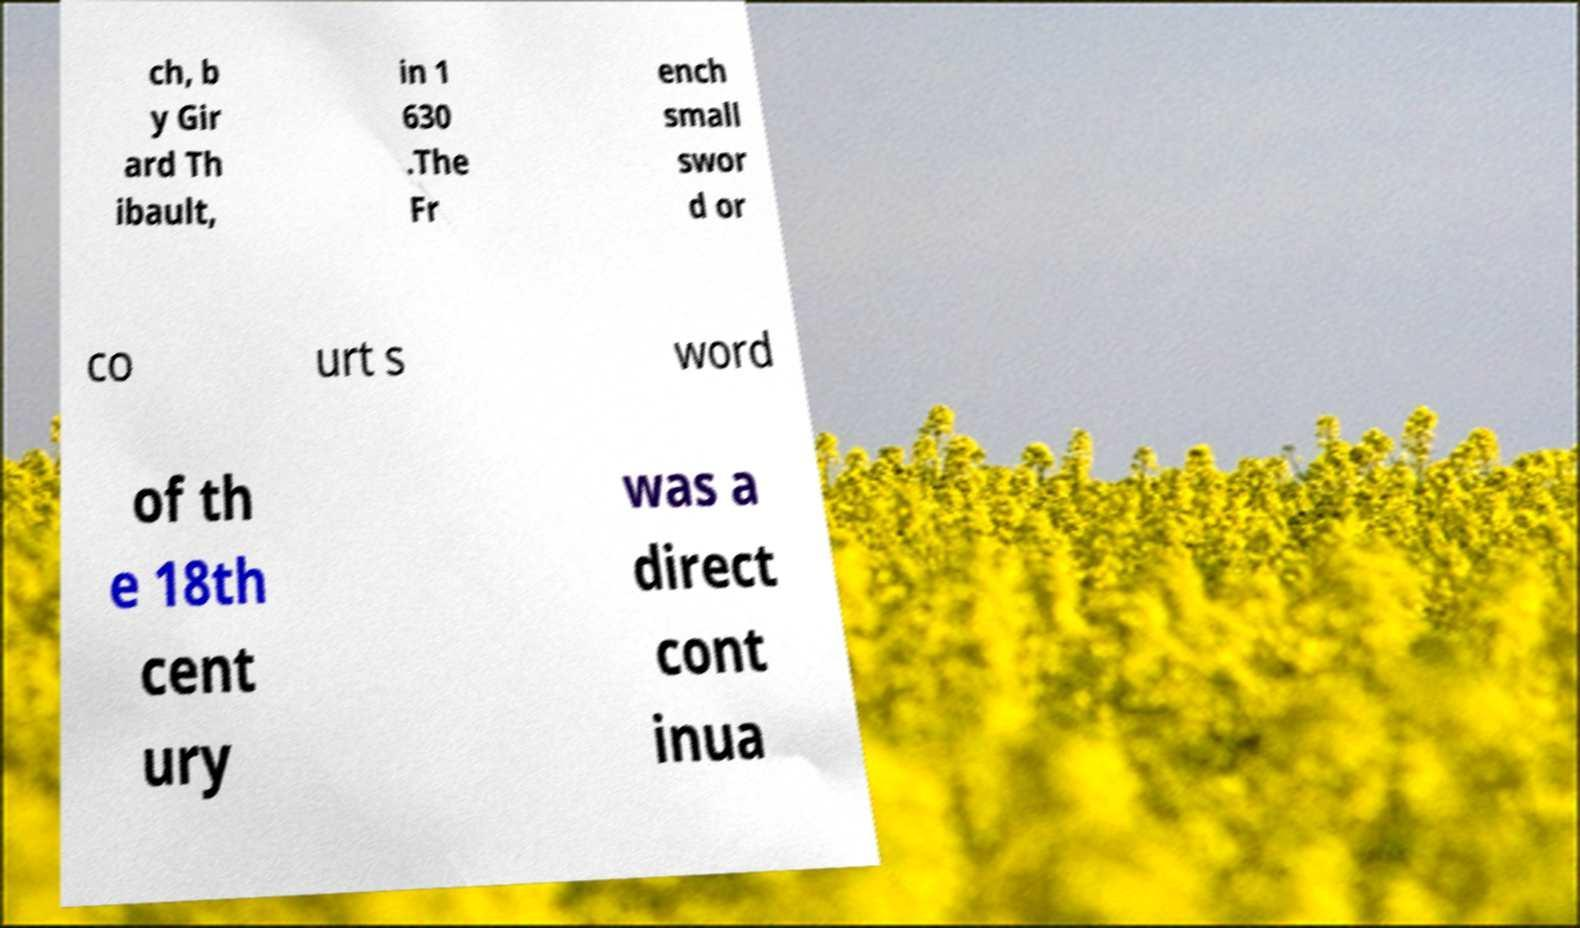Please read and relay the text visible in this image. What does it say? ch, b y Gir ard Th ibault, in 1 630 .The Fr ench small swor d or co urt s word of th e 18th cent ury was a direct cont inua 